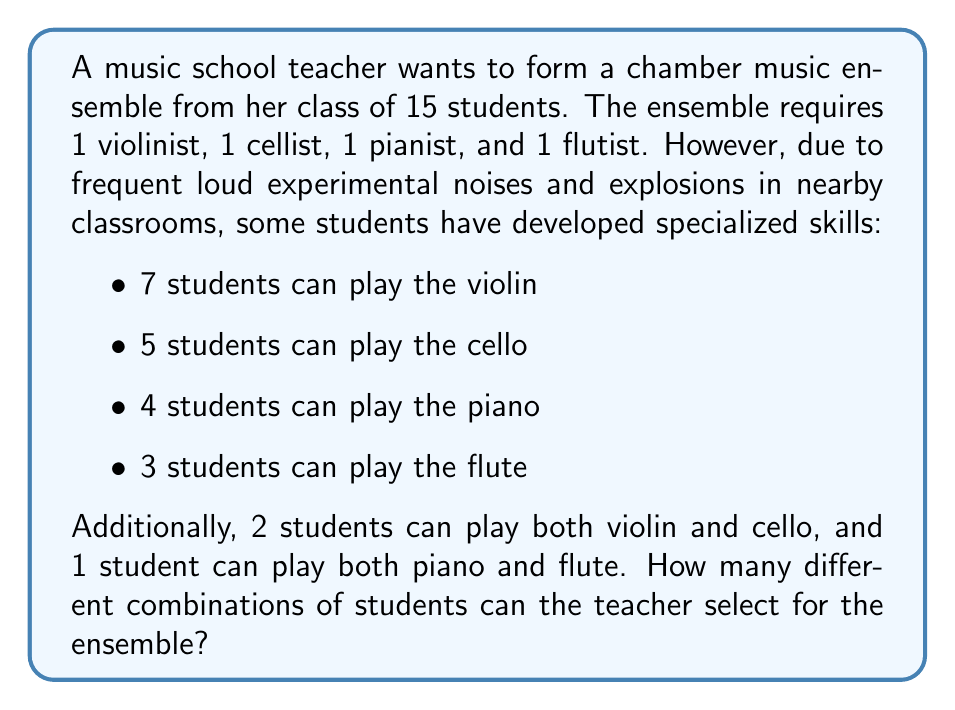Teach me how to tackle this problem. Let's approach this step-by-step:

1) First, we need to calculate the number of students who can play each instrument exclusively:

   Violin only: $7 - 2 = 5$
   Cello only: $5 - 2 = 3$
   Piano only: $4 - 1 = 3$
   Flute only: $3 - 1 = 2$

2) Now, we can use the multiplication principle to calculate the number of combinations:

   $$(5 + 2) \times (3 + 2) \times (3 + 1) \times (2 + 1)$$

   Where:
   - $(5 + 2)$ represents 5 violin-only players plus 2 who can play both violin and cello
   - $(3 + 2)$ represents 3 cello-only players plus 2 who can play both violin and cello
   - $(3 + 1)$ represents 3 piano-only players plus 1 who can play both piano and flute
   - $(2 + 1)$ represents 2 flute-only players plus 1 who can play both piano and flute

3) Calculate:

   $$7 \times 5 \times 4 \times 3 = 420$$

Therefore, there are 420 different possible combinations for the ensemble.
Answer: 420 combinations 